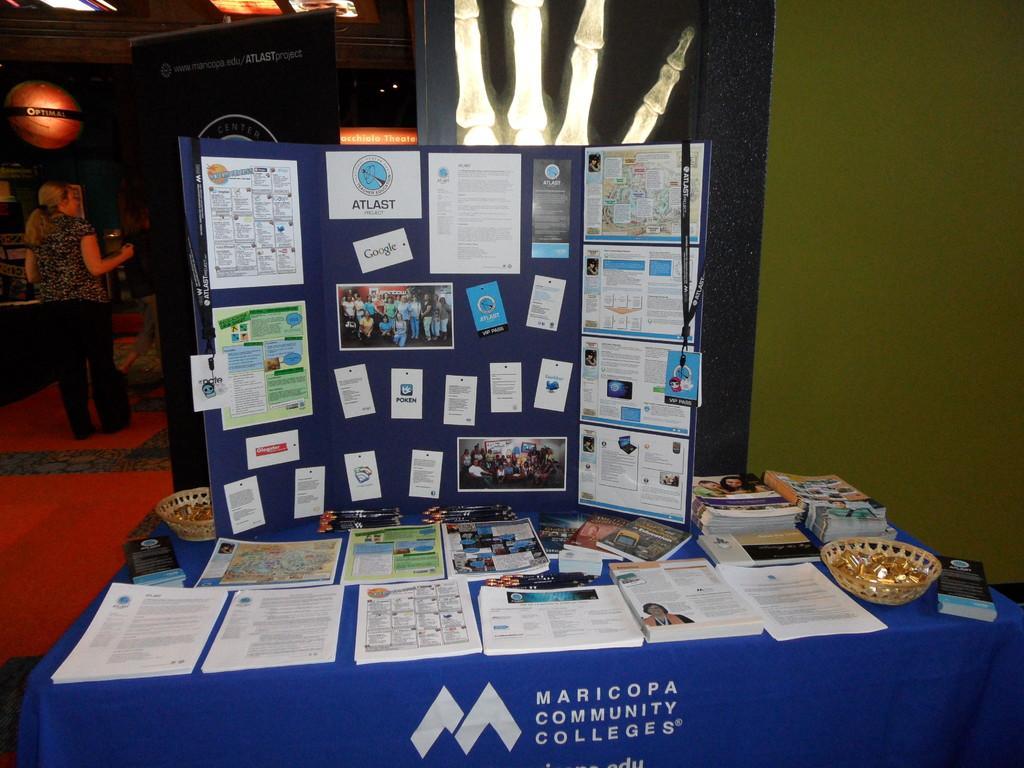Can you describe this image briefly? In the foreground we can see a table which is covered with a cloth and we can see the books on the table. We can see a woman standing, wearing clothes and she is on the left side. 